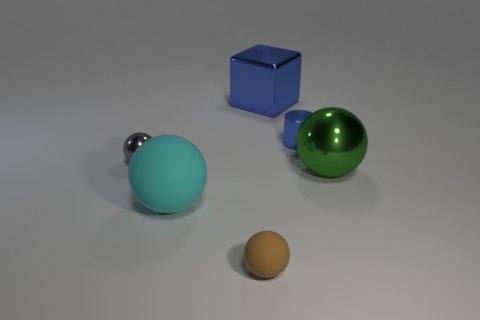Subtract all large green shiny spheres. How many spheres are left? 3 Subtract all cyan balls. How many balls are left? 3 Subtract 1 spheres. How many spheres are left? 3 Subtract all cylinders. How many objects are left? 5 Add 3 big objects. How many big objects exist? 6 Add 1 large gray matte spheres. How many objects exist? 7 Subtract 0 cyan cylinders. How many objects are left? 6 Subtract all red spheres. Subtract all brown cubes. How many spheres are left? 4 Subtract all blue spheres. How many red cylinders are left? 0 Subtract all shiny objects. Subtract all green shiny spheres. How many objects are left? 1 